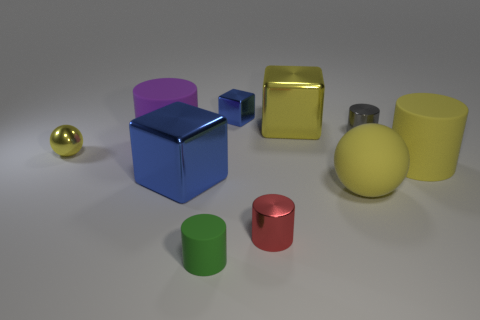Is the number of cubes behind the tiny blue metallic cube greater than the number of red cylinders to the left of the small yellow shiny sphere?
Ensure brevity in your answer.  No. Is the purple rubber cylinder the same size as the yellow shiny block?
Your answer should be compact. Yes. What color is the other small rubber thing that is the same shape as the purple object?
Your answer should be compact. Green. How many shiny blocks have the same color as the large sphere?
Provide a succinct answer. 1. Is the number of large yellow matte cylinders in front of the large sphere greater than the number of red cylinders?
Provide a succinct answer. No. The cylinder that is on the left side of the big metal object in front of the big yellow metal block is what color?
Your answer should be very brief. Purple. How many objects are objects behind the purple thing or big matte objects that are on the right side of the small rubber cylinder?
Your answer should be very brief. 5. The large sphere is what color?
Ensure brevity in your answer.  Yellow. How many blue cubes are made of the same material as the gray thing?
Your response must be concise. 2. Are there more big red shiny cylinders than gray cylinders?
Make the answer very short. No. 